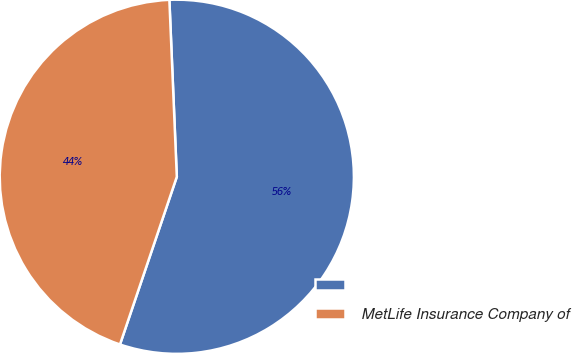Convert chart. <chart><loc_0><loc_0><loc_500><loc_500><pie_chart><ecel><fcel>MetLife Insurance Company of<nl><fcel>55.87%<fcel>44.13%<nl></chart> 